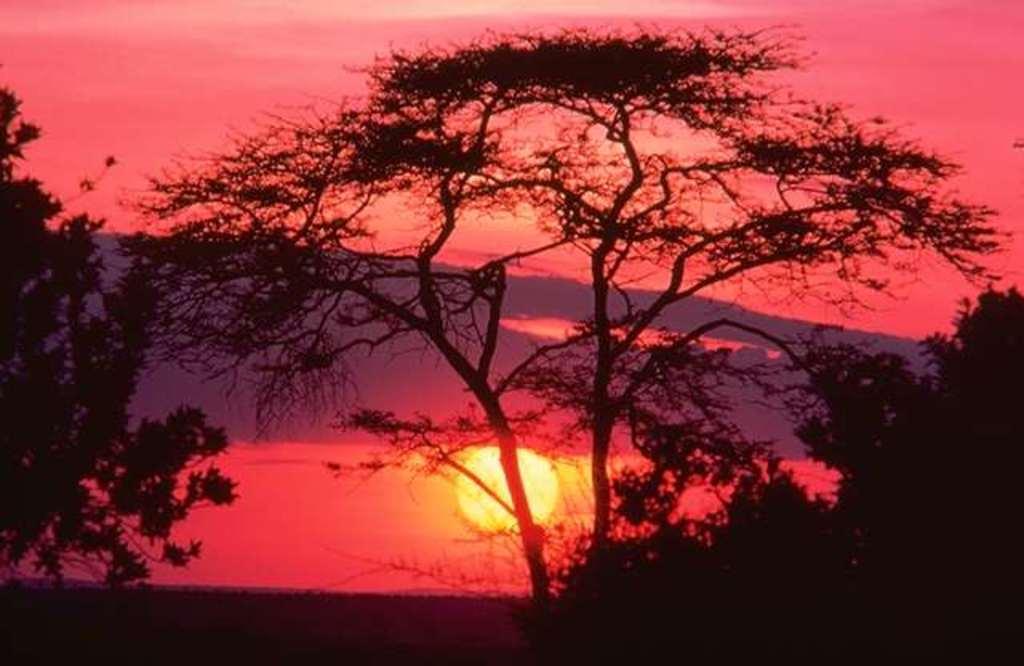Please provide a concise description of this image. In this image we can see the sun in the red sky and there are some trees. 